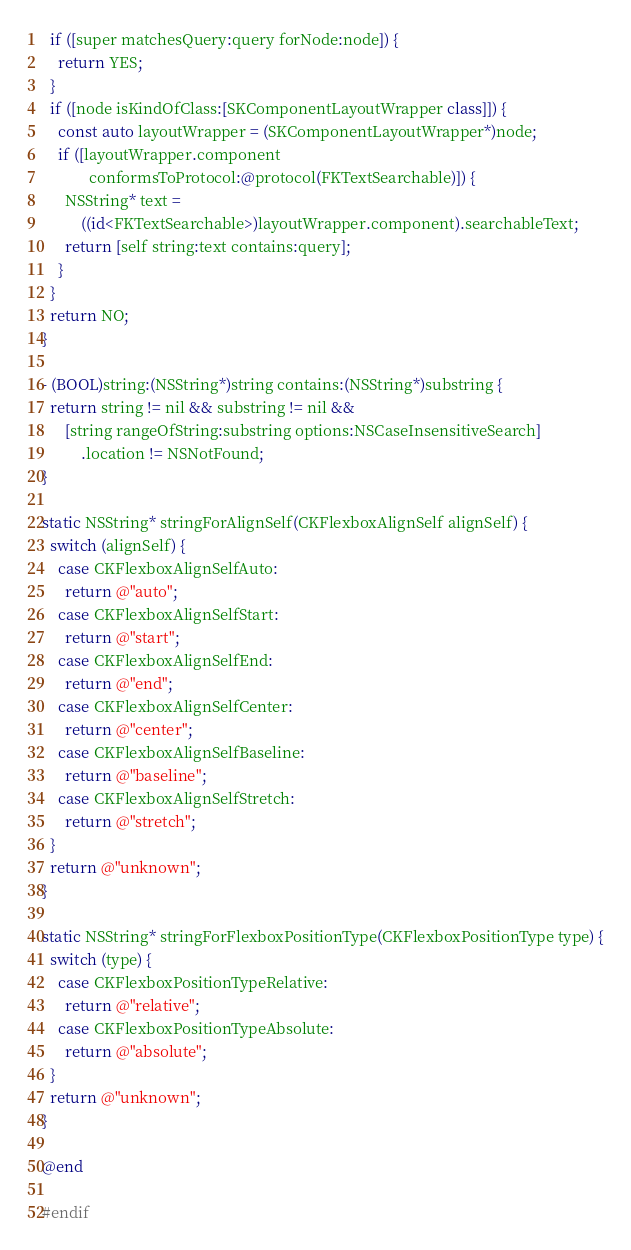<code> <loc_0><loc_0><loc_500><loc_500><_ObjectiveC_>  if ([super matchesQuery:query forNode:node]) {
    return YES;
  }
  if ([node isKindOfClass:[SKComponentLayoutWrapper class]]) {
    const auto layoutWrapper = (SKComponentLayoutWrapper*)node;
    if ([layoutWrapper.component
            conformsToProtocol:@protocol(FKTextSearchable)]) {
      NSString* text =
          ((id<FKTextSearchable>)layoutWrapper.component).searchableText;
      return [self string:text contains:query];
    }
  }
  return NO;
}

- (BOOL)string:(NSString*)string contains:(NSString*)substring {
  return string != nil && substring != nil &&
      [string rangeOfString:substring options:NSCaseInsensitiveSearch]
          .location != NSNotFound;
}

static NSString* stringForAlignSelf(CKFlexboxAlignSelf alignSelf) {
  switch (alignSelf) {
    case CKFlexboxAlignSelfAuto:
      return @"auto";
    case CKFlexboxAlignSelfStart:
      return @"start";
    case CKFlexboxAlignSelfEnd:
      return @"end";
    case CKFlexboxAlignSelfCenter:
      return @"center";
    case CKFlexboxAlignSelfBaseline:
      return @"baseline";
    case CKFlexboxAlignSelfStretch:
      return @"stretch";
  }
  return @"unknown";
}

static NSString* stringForFlexboxPositionType(CKFlexboxPositionType type) {
  switch (type) {
    case CKFlexboxPositionTypeRelative:
      return @"relative";
    case CKFlexboxPositionTypeAbsolute:
      return @"absolute";
  }
  return @"unknown";
}

@end

#endif
</code> 